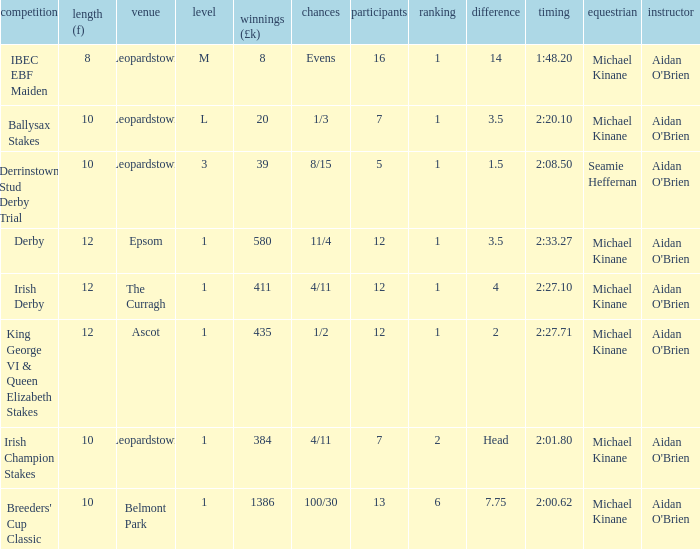Name the highest Dist (f) with Odds of 11/4 and a Placing larger than 1? None. 